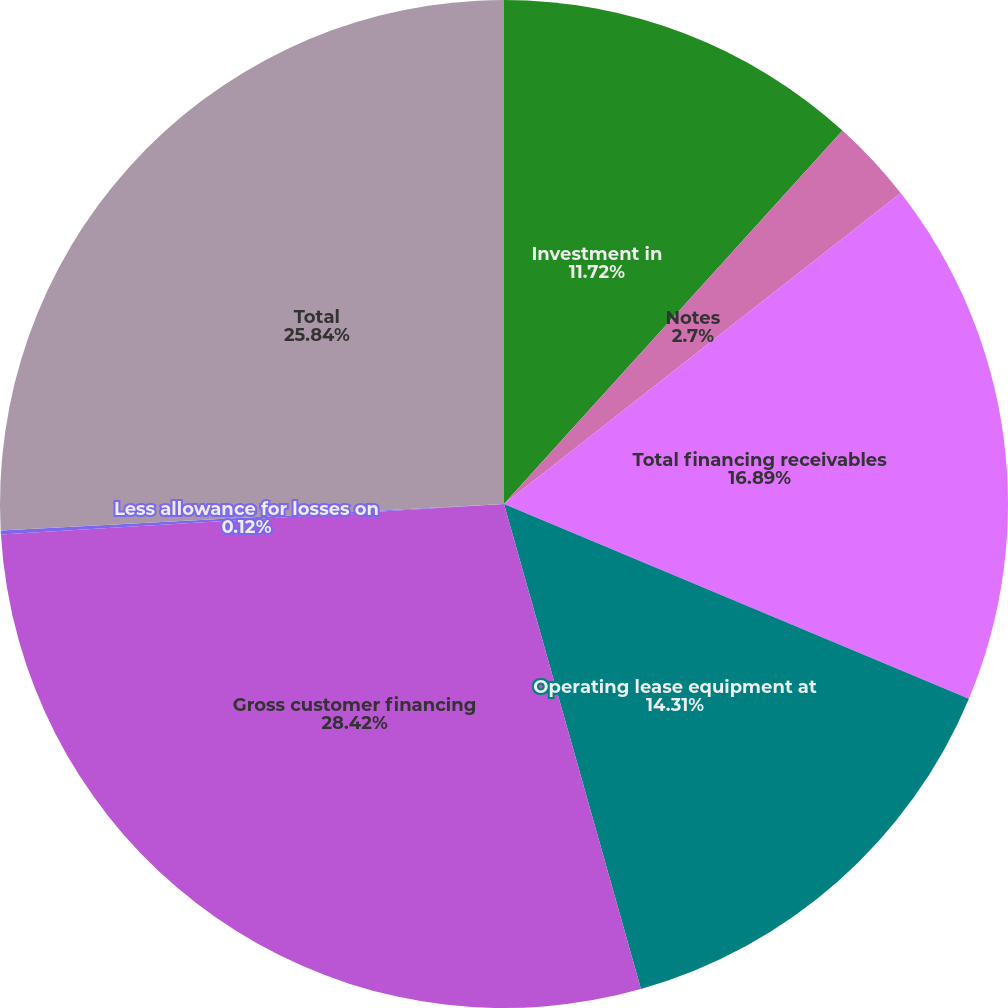<chart> <loc_0><loc_0><loc_500><loc_500><pie_chart><fcel>Investment in<fcel>Notes<fcel>Total financing receivables<fcel>Operating lease equipment at<fcel>Gross customer financing<fcel>Less allowance for losses on<fcel>Total<nl><fcel>11.72%<fcel>2.7%<fcel>16.89%<fcel>14.31%<fcel>28.42%<fcel>0.12%<fcel>25.84%<nl></chart> 